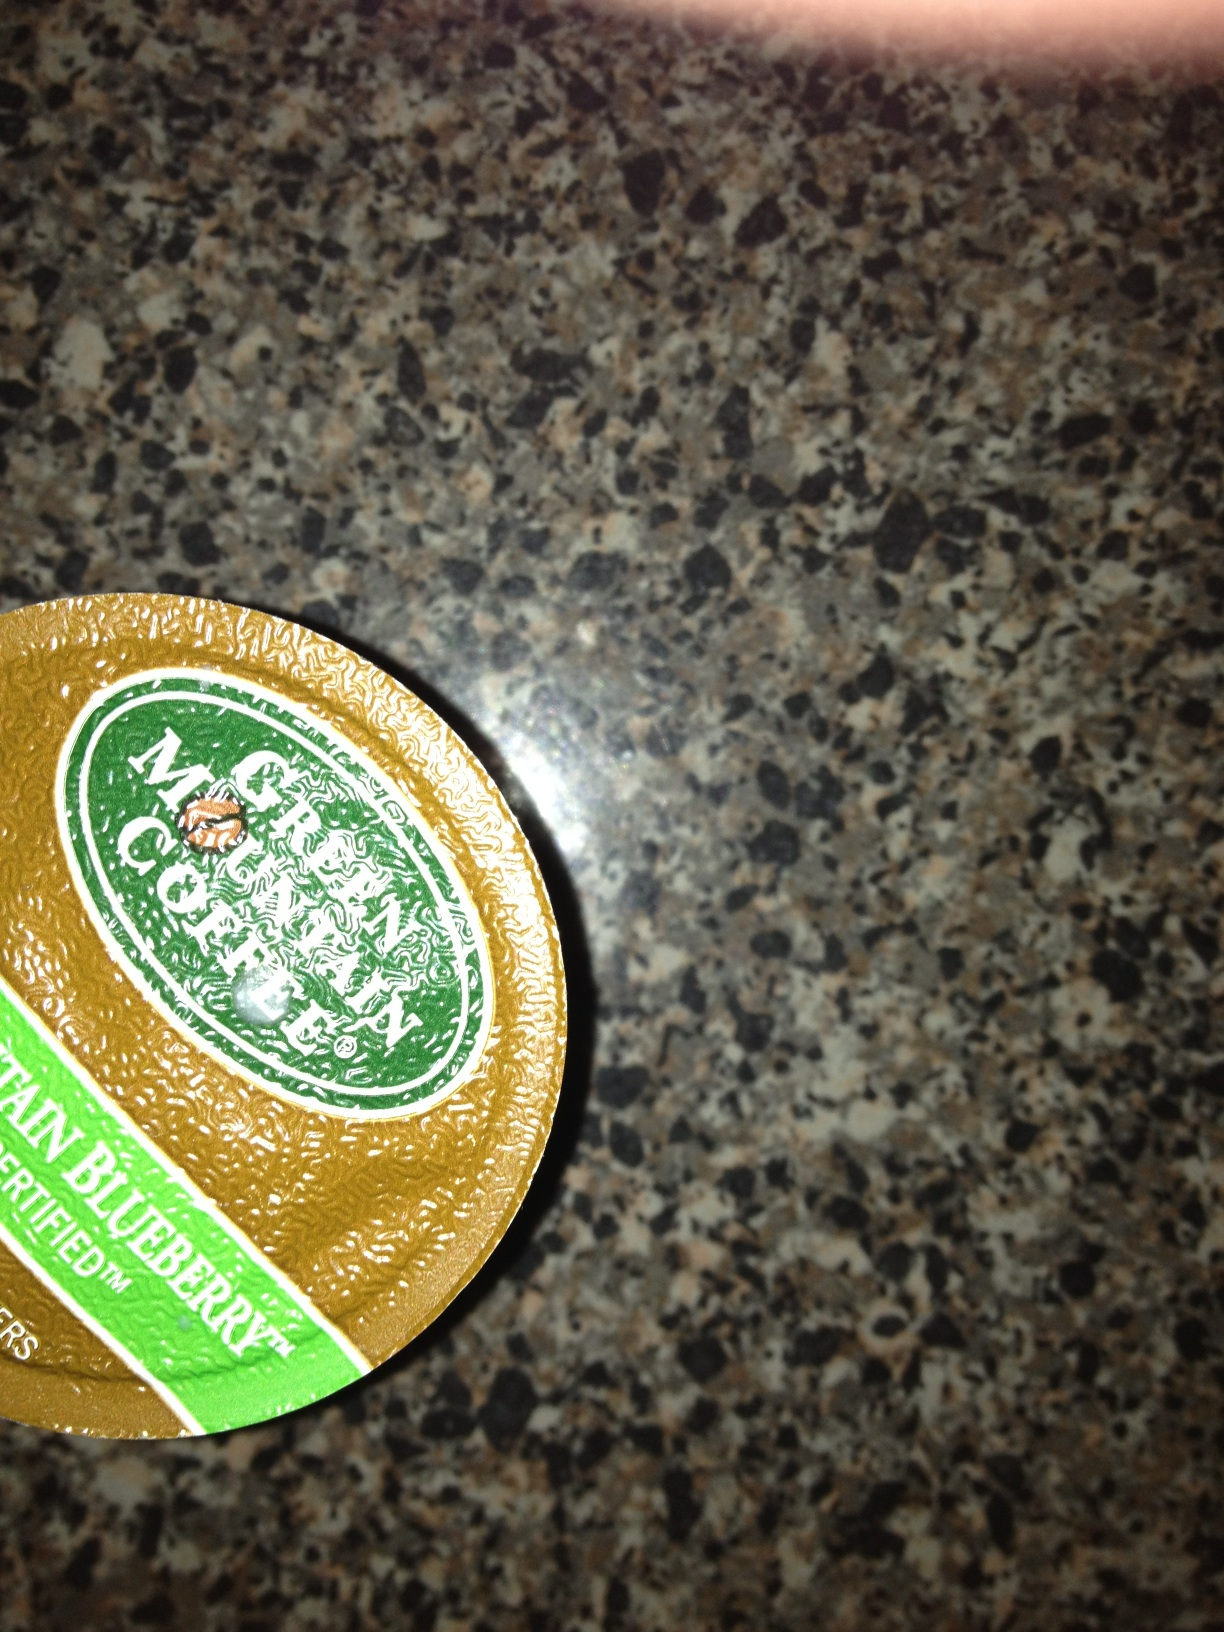How is Mountain Blueberry coffee best enjoyed? Mountain Blueberry coffee is best enjoyed in a variety of ways, depending on your personal preference. Some people love it brewed hot, enjoying the warm and comforting blend of blueberry and coffee flavors. Others prefer it iced, especially in warmer weather, to enjoy a refreshing and cool version of the drink. For a truly unique experience, you might even try it as a cold brew to fully appreciate the subtle blueberry notes. What are the health benefits of drinking coffee with fruit flavors like Mountain Blueberry? Coffee itself has numerous health benefits, such as improved cognitive function and increased physical performance due to its caffeine content. Additionally, when infused with fruit flavors like blueberries, you may gain some of the antioxidants and vitamins from the fruit essence. Blueberries, in particular, are known for their high levels of antioxidants, which can help fight inflammation and protect against cell damage. Combining these benefits with your morning coffee can make for a flavorful and potentially healthier beverage. Imagine a world where coffee plants produced coffee beans with natural blueberry flavors! What would this world be like? Imagine a world where coffee plants have evolved to naturally produce beans with integrated blueberry flavors! This magical world would be filled with lush coffee plantations where the air carries a sweet and fruity aroma. Farmers would talk about the perfect blend of soil and climate that allows these unique plants to thrive. Coffee shops would offer an array of naturally flavored coffees without the need for additional syrups or flavorings. Such a world would be a coffee lover's paradise, with endless possibilities for innovative and delicious coffee creations. The natural blueberry flavor would not only enhance the coffee-drinking experience but would also offer new culinary avenues, encouraging chefs and baristas to experiment with unique and delightful beverage concoctions. 